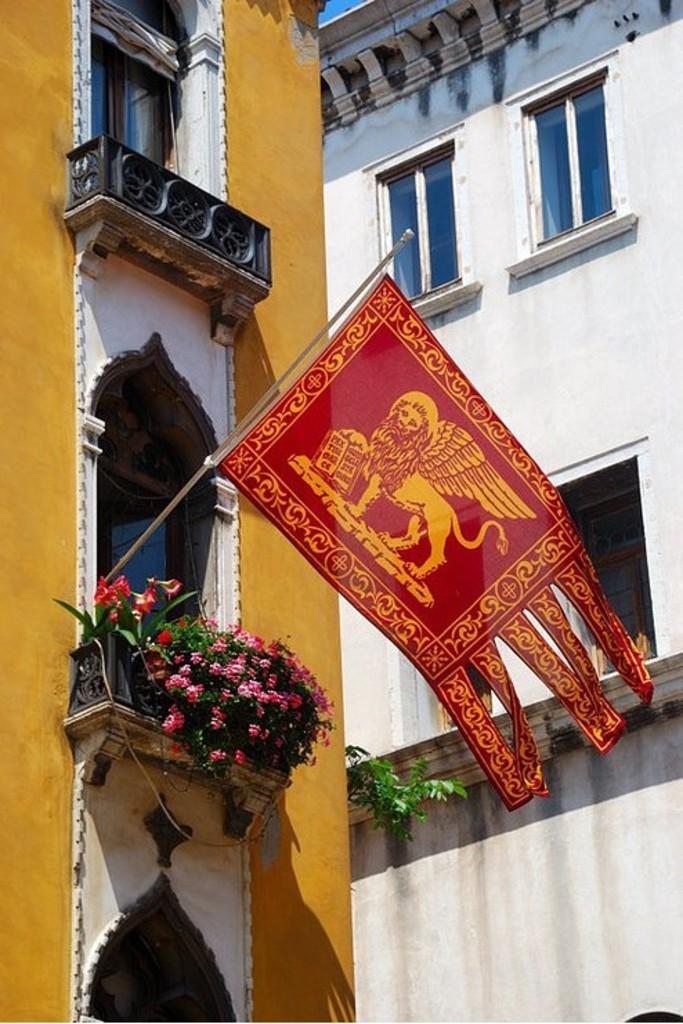Can you describe this image briefly? In this picture we can see some buildings, among them one building has attached flag and we can see some potted plants. 